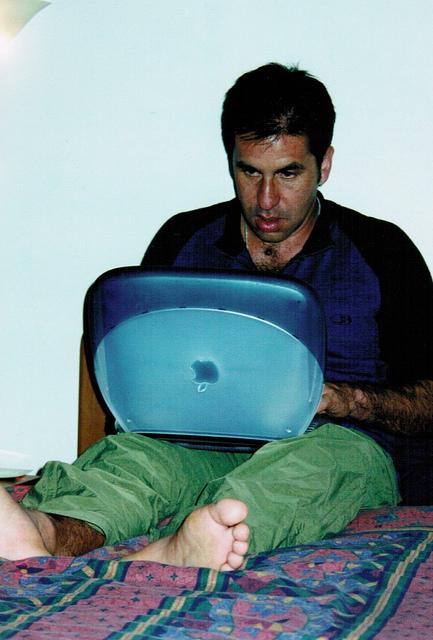What font is used in Apple logo?

Choices:
A) slab serif
B) sans
C) helvetica
D) serif helvetica 